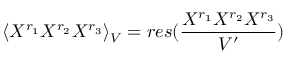<formula> <loc_0><loc_0><loc_500><loc_500>\langle X ^ { r _ { 1 } } X ^ { r _ { 2 } } X ^ { r _ { 3 } } \rangle _ { V } = r e s ( { \frac { X ^ { r _ { 1 } } X ^ { r _ { 2 } } X ^ { r _ { 3 } } } { V ^ { \prime } } } )</formula> 